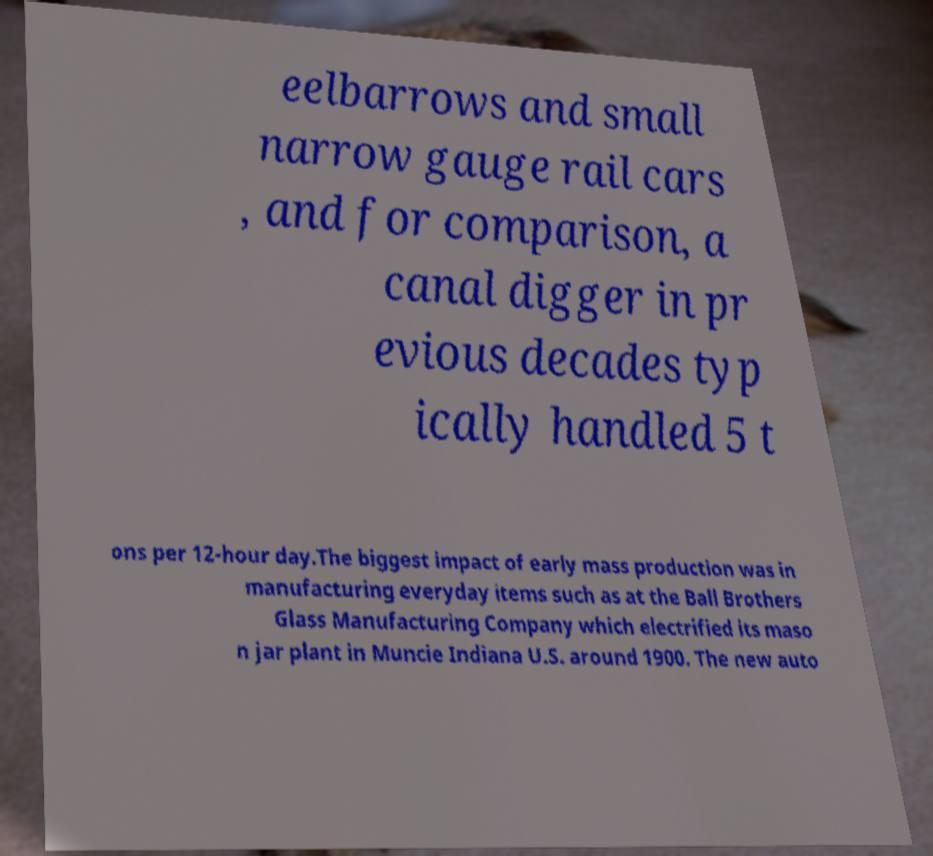Please identify and transcribe the text found in this image. eelbarrows and small narrow gauge rail cars , and for comparison, a canal digger in pr evious decades typ ically handled 5 t ons per 12-hour day.The biggest impact of early mass production was in manufacturing everyday items such as at the Ball Brothers Glass Manufacturing Company which electrified its maso n jar plant in Muncie Indiana U.S. around 1900. The new auto 